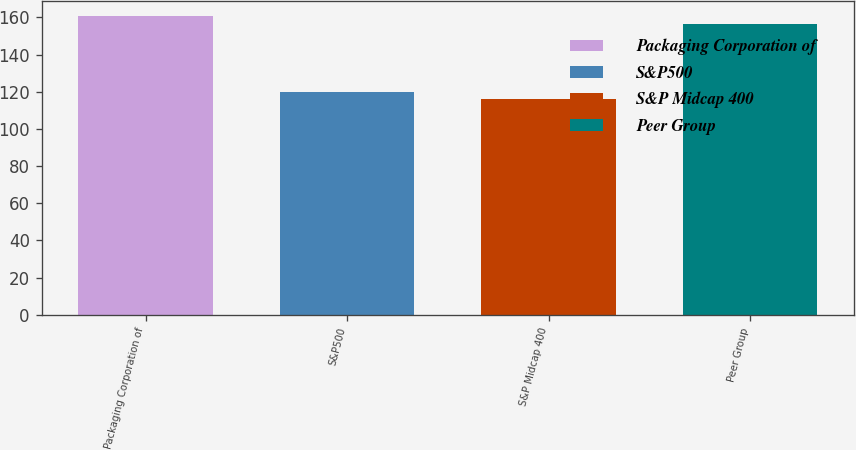Convert chart. <chart><loc_0><loc_0><loc_500><loc_500><bar_chart><fcel>Packaging Corporation of<fcel>S&P500<fcel>S&P Midcap 400<fcel>Peer Group<nl><fcel>160.93<fcel>120.1<fcel>115.84<fcel>156.67<nl></chart> 